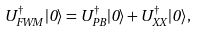<formula> <loc_0><loc_0><loc_500><loc_500>U _ { F W M } ^ { \dag } | 0 \rangle = U _ { P B } ^ { \dag } | 0 \rangle + U _ { X X } ^ { \dag } | 0 \rangle ,</formula> 